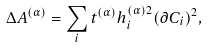<formula> <loc_0><loc_0><loc_500><loc_500>\Delta A ^ { ( \alpha ) } = \sum _ { i } t ^ { ( \alpha ) } h _ { i } ^ { ( \alpha ) 2 } ( \partial C _ { i } ) ^ { 2 } ,</formula> 